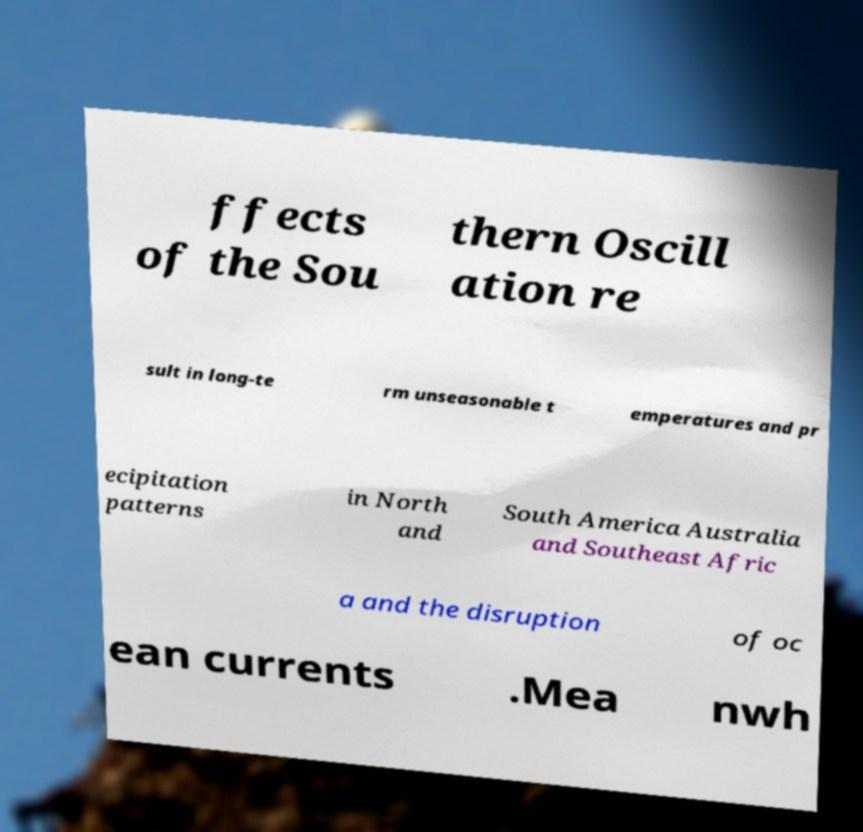Please identify and transcribe the text found in this image. ffects of the Sou thern Oscill ation re sult in long-te rm unseasonable t emperatures and pr ecipitation patterns in North and South America Australia and Southeast Afric a and the disruption of oc ean currents .Mea nwh 